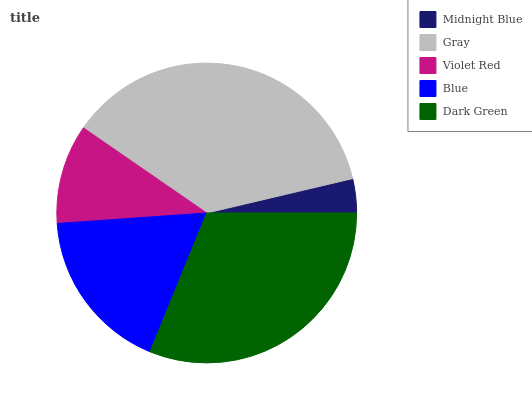Is Midnight Blue the minimum?
Answer yes or no. Yes. Is Gray the maximum?
Answer yes or no. Yes. Is Violet Red the minimum?
Answer yes or no. No. Is Violet Red the maximum?
Answer yes or no. No. Is Gray greater than Violet Red?
Answer yes or no. Yes. Is Violet Red less than Gray?
Answer yes or no. Yes. Is Violet Red greater than Gray?
Answer yes or no. No. Is Gray less than Violet Red?
Answer yes or no. No. Is Blue the high median?
Answer yes or no. Yes. Is Blue the low median?
Answer yes or no. Yes. Is Gray the high median?
Answer yes or no. No. Is Dark Green the low median?
Answer yes or no. No. 